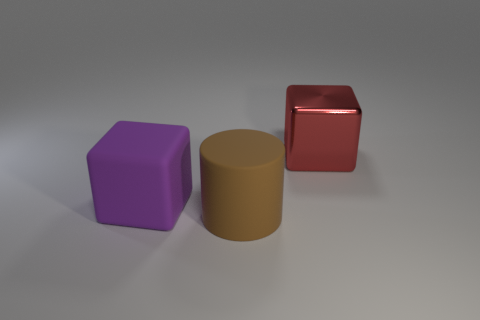Are there any other things that are the same material as the large red block?
Ensure brevity in your answer.  No. How many other objects are the same shape as the purple matte object?
Offer a very short reply. 1. What number of brown objects are cylinders or small things?
Your answer should be compact. 1. The thing that is made of the same material as the purple cube is what color?
Provide a short and direct response. Brown. Is the thing left of the brown rubber cylinder made of the same material as the large object that is in front of the matte cube?
Offer a very short reply. Yes. There is a big thing that is to the right of the brown object; what is its material?
Provide a succinct answer. Metal. There is a thing that is behind the rubber block; is its shape the same as the thing that is left of the brown cylinder?
Offer a very short reply. Yes. Are any large cubes visible?
Your response must be concise. Yes. There is another large purple thing that is the same shape as the metal object; what is it made of?
Provide a succinct answer. Rubber. Are there any matte objects behind the brown thing?
Your answer should be compact. Yes. 